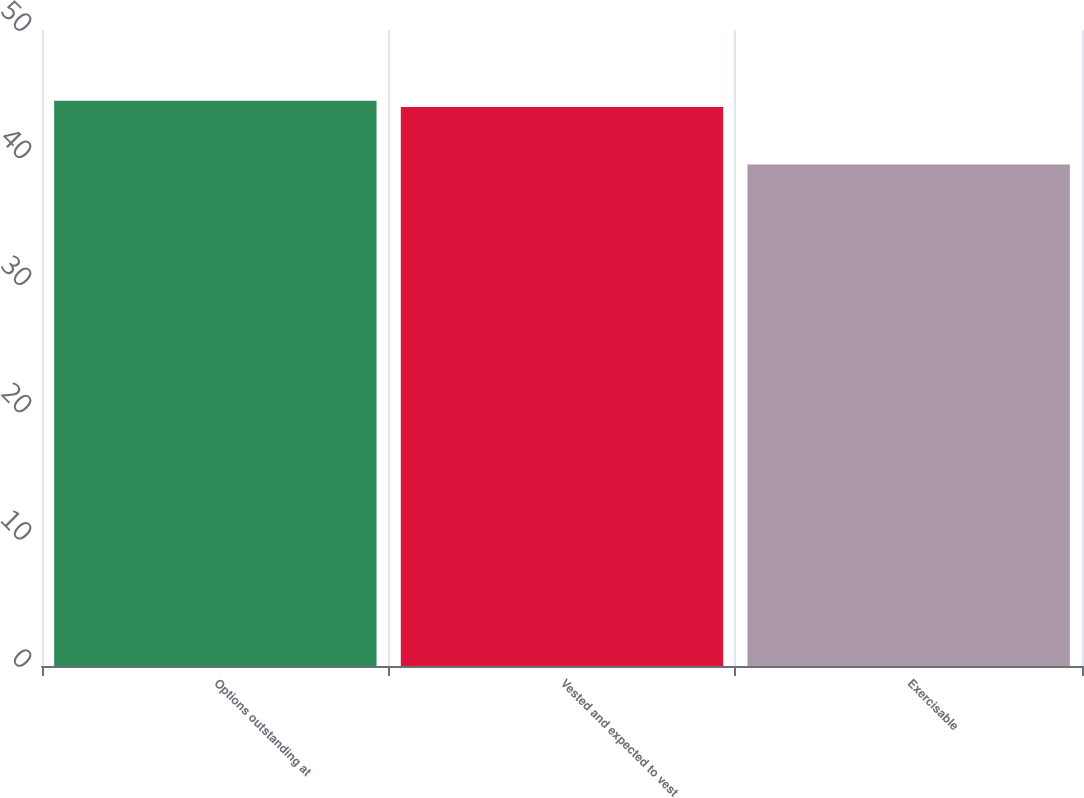Convert chart to OTSL. <chart><loc_0><loc_0><loc_500><loc_500><bar_chart><fcel>Options outstanding at<fcel>Vested and expected to vest<fcel>Exercisable<nl><fcel>44.43<fcel>43.95<fcel>39.42<nl></chart> 